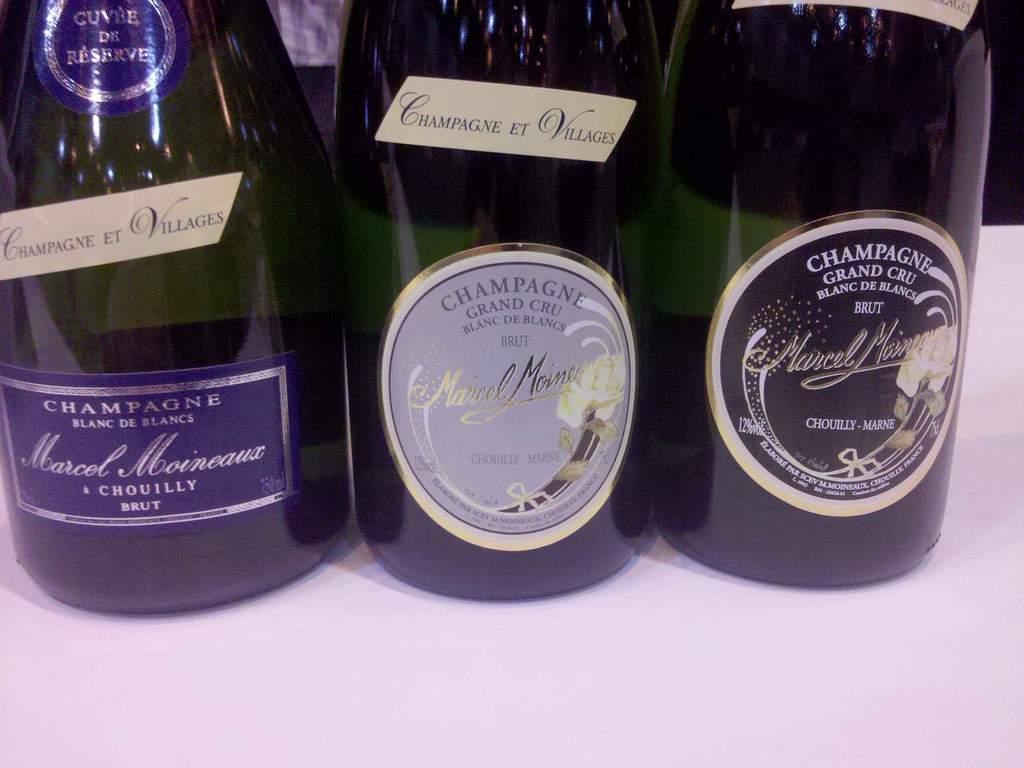What type of alcohol is inside the bottles?
Offer a very short reply. Champagne. What champagne is on the right?
Your answer should be very brief. Grand cru. 